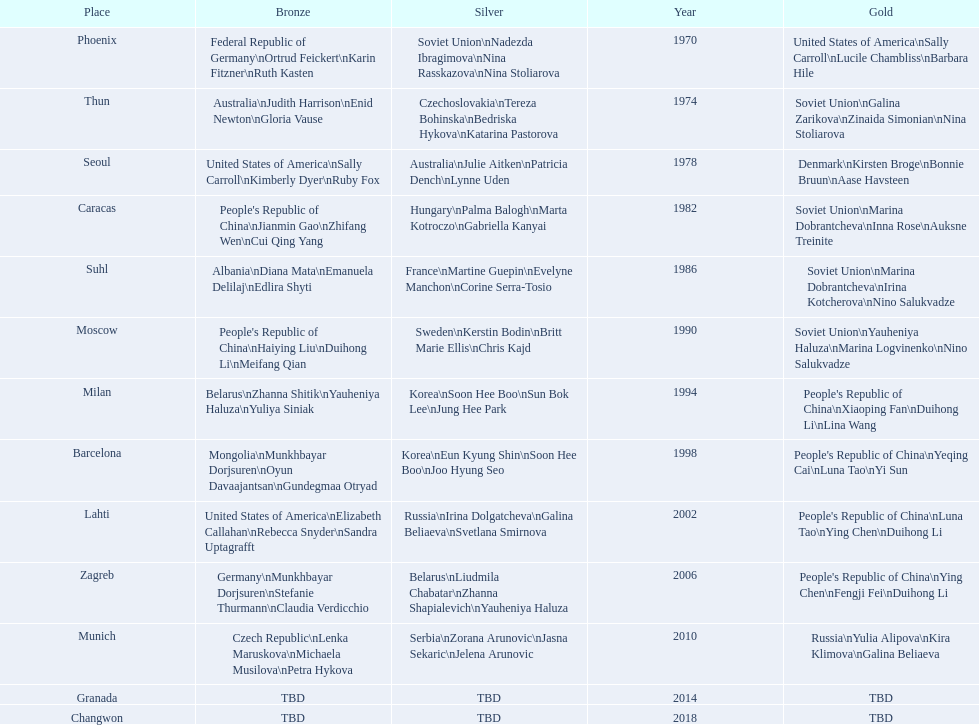Whose name is listed before bonnie bruun's in the gold column? Kirsten Broge. 